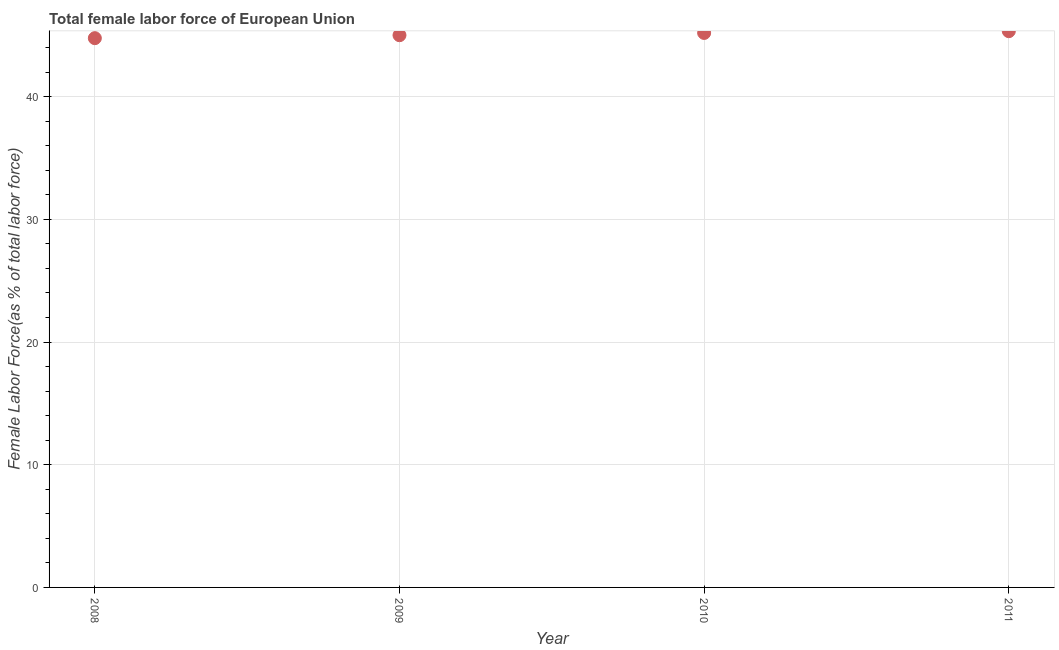What is the total female labor force in 2008?
Make the answer very short. 44.76. Across all years, what is the maximum total female labor force?
Your answer should be very brief. 45.33. Across all years, what is the minimum total female labor force?
Your answer should be compact. 44.76. In which year was the total female labor force maximum?
Make the answer very short. 2011. What is the sum of the total female labor force?
Your answer should be compact. 180.29. What is the difference between the total female labor force in 2008 and 2009?
Offer a very short reply. -0.24. What is the average total female labor force per year?
Your response must be concise. 45.07. What is the median total female labor force?
Make the answer very short. 45.1. Do a majority of the years between 2009 and 2011 (inclusive) have total female labor force greater than 42 %?
Your answer should be compact. Yes. What is the ratio of the total female labor force in 2009 to that in 2011?
Make the answer very short. 0.99. Is the total female labor force in 2008 less than that in 2011?
Your response must be concise. Yes. Is the difference between the total female labor force in 2008 and 2009 greater than the difference between any two years?
Give a very brief answer. No. What is the difference between the highest and the second highest total female labor force?
Your answer should be compact. 0.14. What is the difference between the highest and the lowest total female labor force?
Ensure brevity in your answer.  0.57. How many dotlines are there?
Make the answer very short. 1. What is the difference between two consecutive major ticks on the Y-axis?
Offer a terse response. 10. Does the graph contain any zero values?
Keep it short and to the point. No. What is the title of the graph?
Ensure brevity in your answer.  Total female labor force of European Union. What is the label or title of the X-axis?
Your answer should be very brief. Year. What is the label or title of the Y-axis?
Ensure brevity in your answer.  Female Labor Force(as % of total labor force). What is the Female Labor Force(as % of total labor force) in 2008?
Provide a short and direct response. 44.76. What is the Female Labor Force(as % of total labor force) in 2009?
Your response must be concise. 45. What is the Female Labor Force(as % of total labor force) in 2010?
Keep it short and to the point. 45.19. What is the Female Labor Force(as % of total labor force) in 2011?
Your answer should be compact. 45.33. What is the difference between the Female Labor Force(as % of total labor force) in 2008 and 2009?
Provide a succinct answer. -0.24. What is the difference between the Female Labor Force(as % of total labor force) in 2008 and 2010?
Provide a short and direct response. -0.42. What is the difference between the Female Labor Force(as % of total labor force) in 2008 and 2011?
Give a very brief answer. -0.57. What is the difference between the Female Labor Force(as % of total labor force) in 2009 and 2010?
Provide a short and direct response. -0.18. What is the difference between the Female Labor Force(as % of total labor force) in 2009 and 2011?
Keep it short and to the point. -0.33. What is the difference between the Female Labor Force(as % of total labor force) in 2010 and 2011?
Give a very brief answer. -0.14. What is the ratio of the Female Labor Force(as % of total labor force) in 2008 to that in 2009?
Give a very brief answer. 0.99. What is the ratio of the Female Labor Force(as % of total labor force) in 2008 to that in 2010?
Offer a terse response. 0.99. 